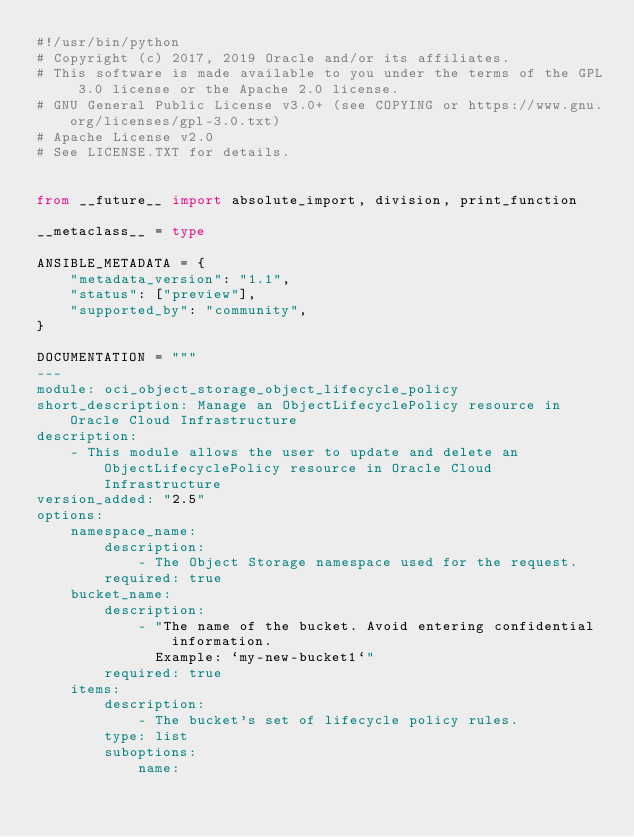<code> <loc_0><loc_0><loc_500><loc_500><_Python_>#!/usr/bin/python
# Copyright (c) 2017, 2019 Oracle and/or its affiliates.
# This software is made available to you under the terms of the GPL 3.0 license or the Apache 2.0 license.
# GNU General Public License v3.0+ (see COPYING or https://www.gnu.org/licenses/gpl-3.0.txt)
# Apache License v2.0
# See LICENSE.TXT for details.


from __future__ import absolute_import, division, print_function

__metaclass__ = type

ANSIBLE_METADATA = {
    "metadata_version": "1.1",
    "status": ["preview"],
    "supported_by": "community",
}

DOCUMENTATION = """
---
module: oci_object_storage_object_lifecycle_policy
short_description: Manage an ObjectLifecyclePolicy resource in Oracle Cloud Infrastructure
description:
    - This module allows the user to update and delete an ObjectLifecyclePolicy resource in Oracle Cloud Infrastructure
version_added: "2.5"
options:
    namespace_name:
        description:
            - The Object Storage namespace used for the request.
        required: true
    bucket_name:
        description:
            - "The name of the bucket. Avoid entering confidential information.
              Example: `my-new-bucket1`"
        required: true
    items:
        description:
            - The bucket's set of lifecycle policy rules.
        type: list
        suboptions:
            name:</code> 